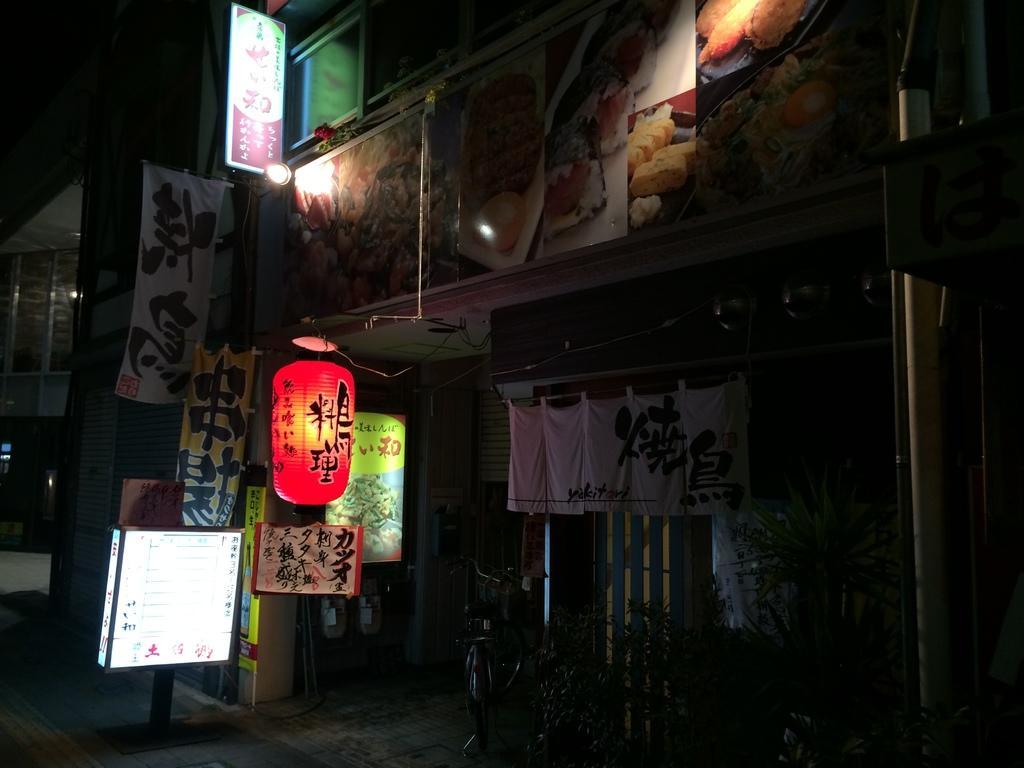Describe this image in one or two sentences. In the image there is a cycle on the floor. And there is a building with walls, posters with images, flags, banners and also there is a pole on the footpath with board. There are few clothes hanging to the rope. On the left side of the image there is a building with glass windows. 